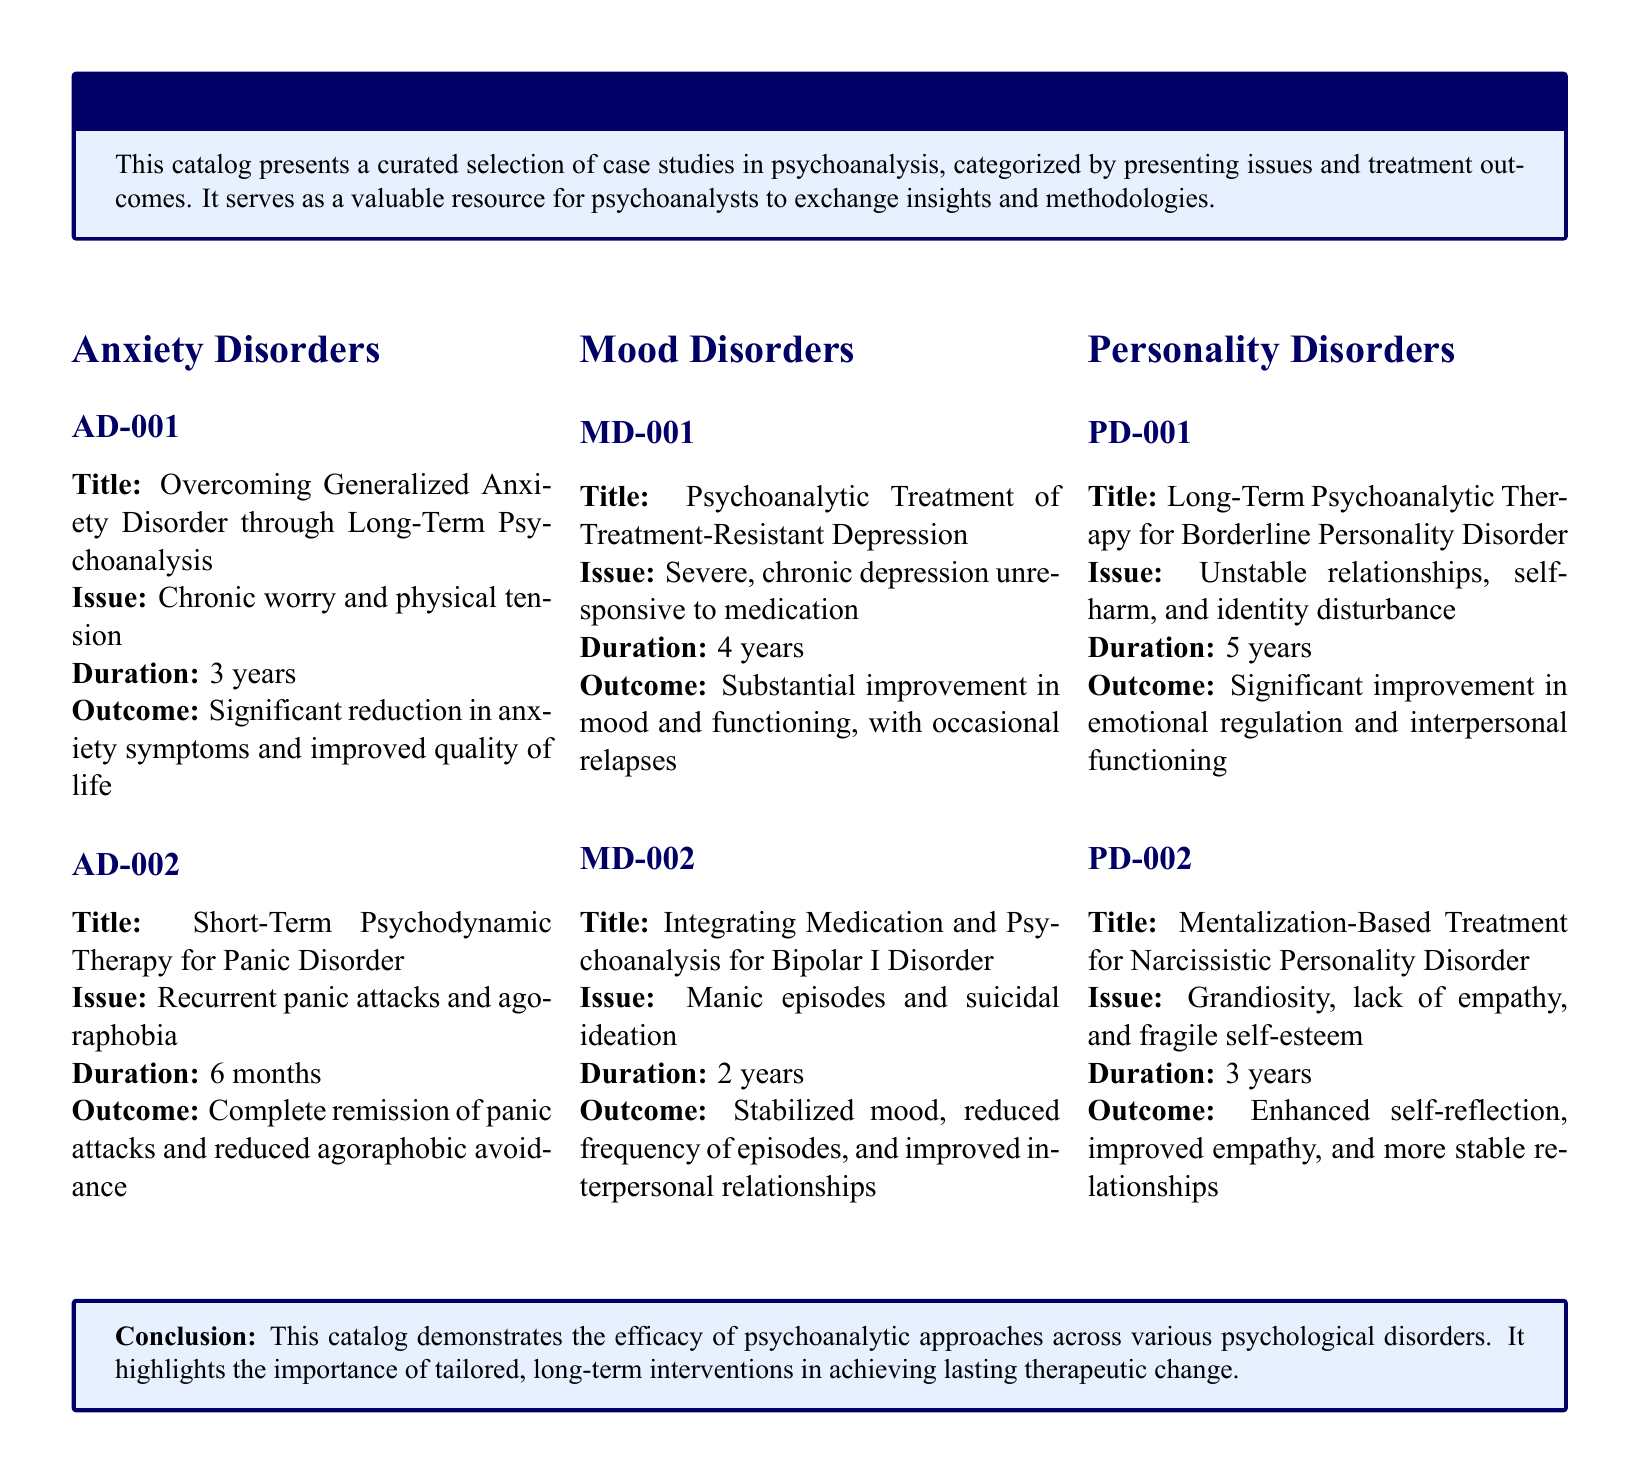What is the title of case AD-001? The title for case AD-001 is "Overcoming Generalized Anxiety Disorder through Long-Term Psychoanalysis."
Answer: "Overcoming Generalized Anxiety Disorder through Long-Term Psychoanalysis." What is the duration of case MD-002? The duration for case MD-002 is specified as 2 years.
Answer: 2 years What presenting issue is discussed in case PD-002? The presenting issue in case PD-002 is "Grandiosity, lack of empathy, and fragile self-esteem."
Answer: "Grandiosity, lack of empathy, and fragile self-esteem." What was the outcome of case AD-002? The outcome of case AD-002 is described as "Complete remission of panic attacks and reduced agoraphobic avoidance."
Answer: "Complete remission of panic attacks and reduced agoraphobic avoidance." How many years of therapy were involved in case PD-001? Case PD-001 involved 5 years of therapy.
Answer: 5 years What type of therapy was used in case MD-001? The therapy used in case MD-001 was "Psychoanalytic Treatment."
Answer: "Psychoanalytic Treatment" How many case studies are listed under Anxiety Disorders? There are 2 case studies listed under Anxiety Disorders.
Answer: 2 Which disorder is associated with the case study titled "Mentalization-Based Treatment for Narcissistic Personality Disorder"? This case study is associated with Narcissistic Personality Disorder.
Answer: Narcissistic Personality Disorder 